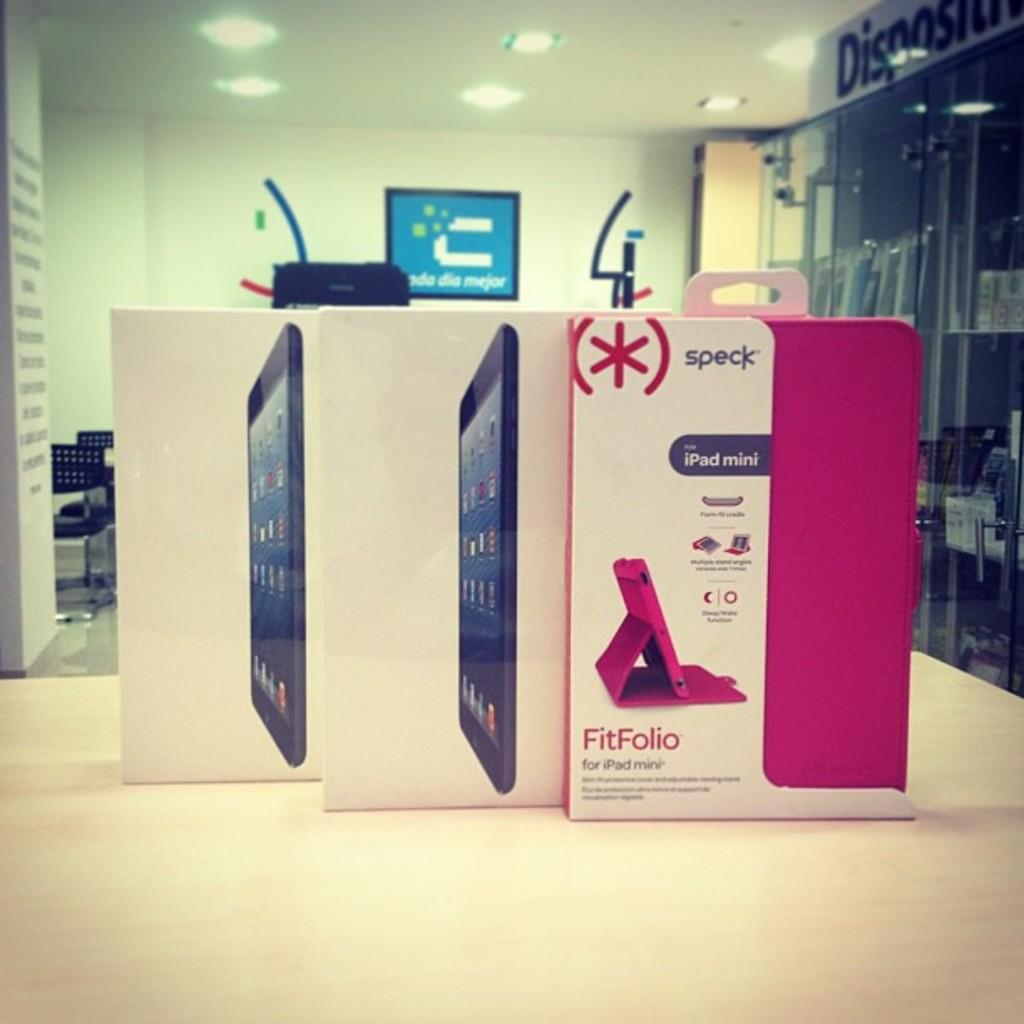What is in the pink box?
Your answer should be compact. Fitfolio. What company makes the product in the box to the right?
Ensure brevity in your answer.  Speck. 